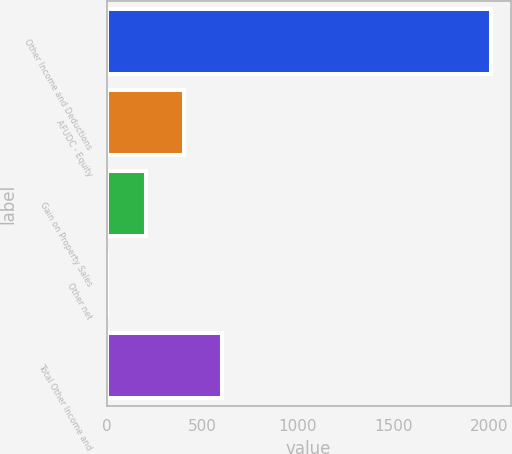Convert chart to OTSL. <chart><loc_0><loc_0><loc_500><loc_500><bar_chart><fcel>Other Income and Deductions<fcel>AFUDC - Equity<fcel>Gain on Property Sales<fcel>Other net<fcel>Total Other Income and<nl><fcel>2010<fcel>404.64<fcel>203.97<fcel>3.3<fcel>605.31<nl></chart> 